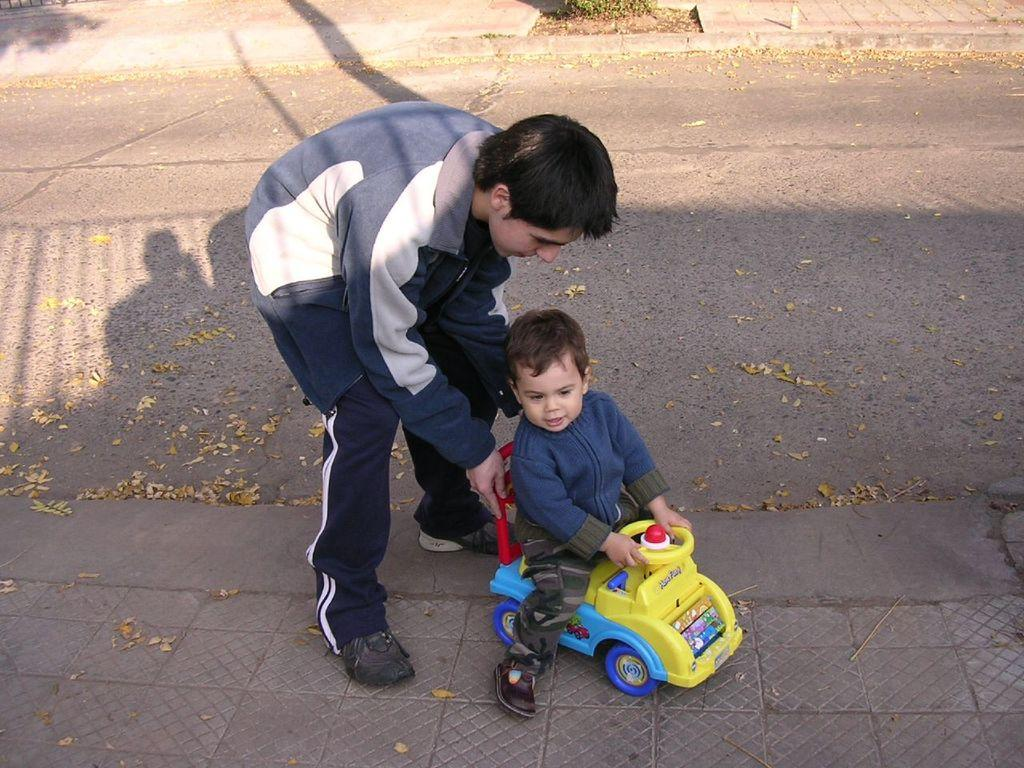What can be seen in the foreground of the image? In the foreground of the image, there are dry leaves, a boy, a kid, a footpath, and a toy. What is the primary subject in the foreground of the image? The primary subjects in the foreground of the image are the boy and the kid. What is present in the middle of the image? In the middle of the image, there is a road. What can be seen at the top of the image? At the top of the image, there is a footpath and a plant. What type of fruit is hanging from the plant at the top of the image? There is no fruit visible on the plant in the image. What kind of test is the boy taking in the foreground of the image? There is no test being taken in the image; the boy and the kid are simply present in the foreground. 